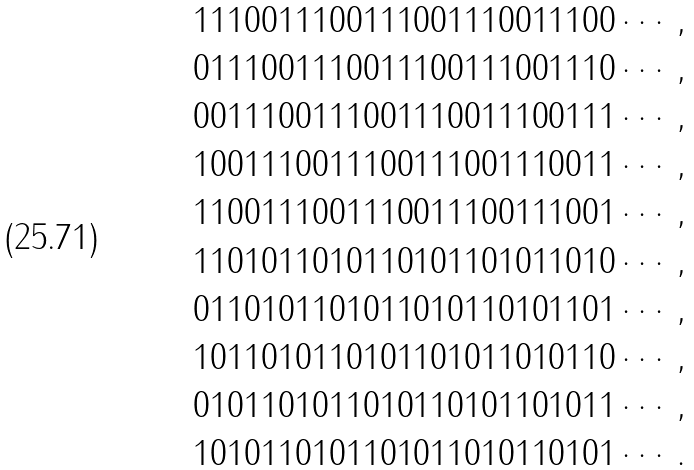Convert formula to latex. <formula><loc_0><loc_0><loc_500><loc_500>1 1 1 0 0 1 1 1 0 0 1 1 1 0 0 1 1 1 0 0 1 1 1 0 0 \cdots , \\ 0 1 1 1 0 0 1 1 1 0 0 1 1 1 0 0 1 1 1 0 0 1 1 1 0 \cdots , \\ 0 0 1 1 1 0 0 1 1 1 0 0 1 1 1 0 0 1 1 1 0 0 1 1 1 \cdots , \\ 1 0 0 1 1 1 0 0 1 1 1 0 0 1 1 1 0 0 1 1 1 0 0 1 1 \cdots , \\ 1 1 0 0 1 1 1 0 0 1 1 1 0 0 1 1 1 0 0 1 1 1 0 0 1 \cdots , \\ 1 1 0 1 0 1 1 0 1 0 1 1 0 1 0 1 1 0 1 0 1 1 0 1 0 \cdots , \\ 0 1 1 0 1 0 1 1 0 1 0 1 1 0 1 0 1 1 0 1 0 1 1 0 1 \cdots , \\ 1 0 1 1 0 1 0 1 1 0 1 0 1 1 0 1 0 1 1 0 1 0 1 1 0 \cdots , \\ 0 1 0 1 1 0 1 0 1 1 0 1 0 1 1 0 1 0 1 1 0 1 0 1 1 \cdots , \\ 1 0 1 0 1 1 0 1 0 1 1 0 1 0 1 1 0 1 0 1 1 0 1 0 1 \cdots .</formula> 